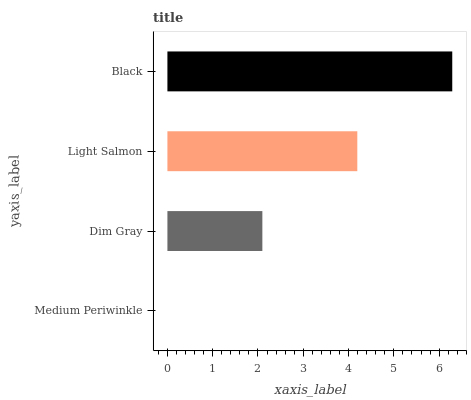Is Medium Periwinkle the minimum?
Answer yes or no. Yes. Is Black the maximum?
Answer yes or no. Yes. Is Dim Gray the minimum?
Answer yes or no. No. Is Dim Gray the maximum?
Answer yes or no. No. Is Dim Gray greater than Medium Periwinkle?
Answer yes or no. Yes. Is Medium Periwinkle less than Dim Gray?
Answer yes or no. Yes. Is Medium Periwinkle greater than Dim Gray?
Answer yes or no. No. Is Dim Gray less than Medium Periwinkle?
Answer yes or no. No. Is Light Salmon the high median?
Answer yes or no. Yes. Is Dim Gray the low median?
Answer yes or no. Yes. Is Black the high median?
Answer yes or no. No. Is Black the low median?
Answer yes or no. No. 